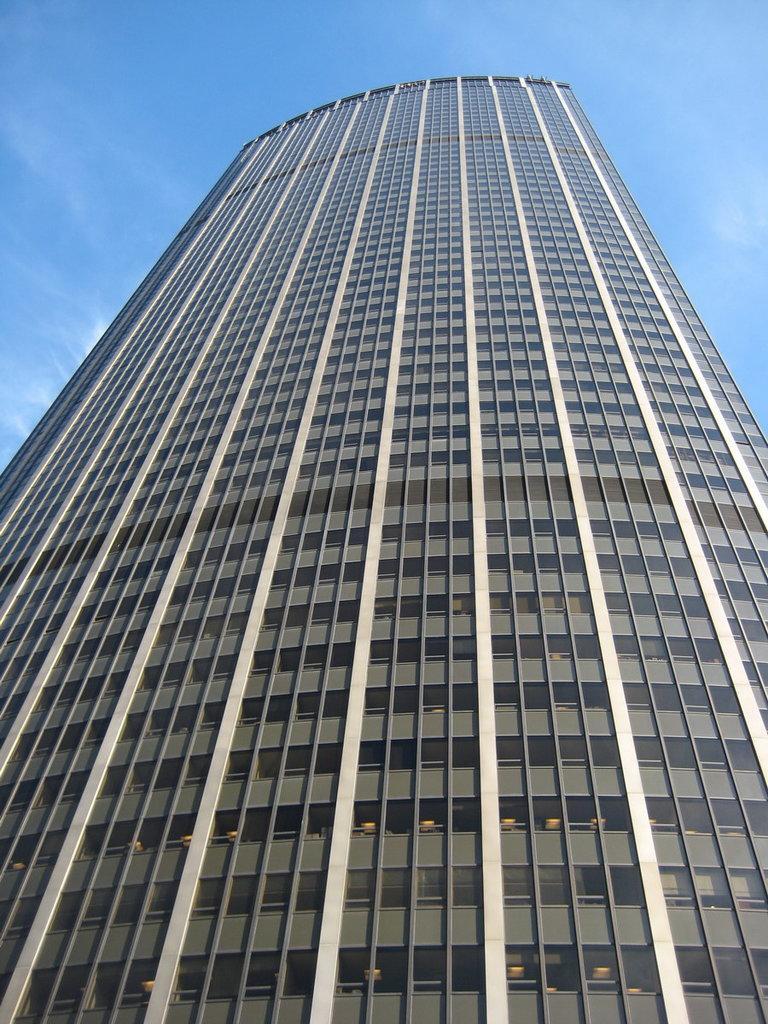Describe this image in one or two sentences. In the foreground of this image, there is a skyscraper and in the background, there is the sky. 